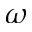<formula> <loc_0><loc_0><loc_500><loc_500>\omega</formula> 